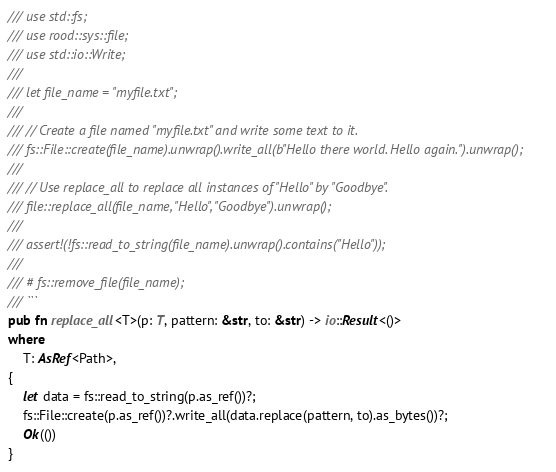<code> <loc_0><loc_0><loc_500><loc_500><_Rust_>/// use std::fs;
/// use rood::sys::file;
/// use std::io::Write;
///
/// let file_name = "myfile.txt";
///
/// // Create a file named "myfile.txt" and write some text to it.
/// fs::File::create(file_name).unwrap().write_all(b"Hello there world. Hello again.").unwrap();
///
/// // Use replace_all to replace all instances of "Hello" by "Goodbye".
/// file::replace_all(file_name, "Hello", "Goodbye").unwrap();
///
/// assert!(!fs::read_to_string(file_name).unwrap().contains("Hello"));
///
/// # fs::remove_file(file_name);
/// ```
pub fn replace_all<T>(p: T, pattern: &str, to: &str) -> io::Result<()>
where
    T: AsRef<Path>,
{
    let data = fs::read_to_string(p.as_ref())?;
    fs::File::create(p.as_ref())?.write_all(data.replace(pattern, to).as_bytes())?;
    Ok(())
}
</code> 